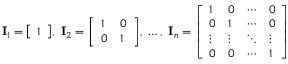<formula> <loc_0><loc_0><loc_500><loc_500>I _ { 1 } = { \left [ \begin{array} { l } { 1 } \end{array} \right ] } , \ I _ { 2 } = { \left [ \begin{array} { l l } { 1 } & { 0 } \\ { 0 } & { 1 } \end{array} \right ] } , \ \dots , \ I _ { n } = { \left [ \begin{array} { l l l l } { 1 } & { 0 } & { \cdots } & { 0 } \\ { 0 } & { 1 } & { \cdots } & { 0 } \\ { \vdots } & { \vdots } & { \ddots } & { \vdots } \\ { 0 } & { 0 } & { \cdots } & { 1 } \end{array} \right ] }</formula> 